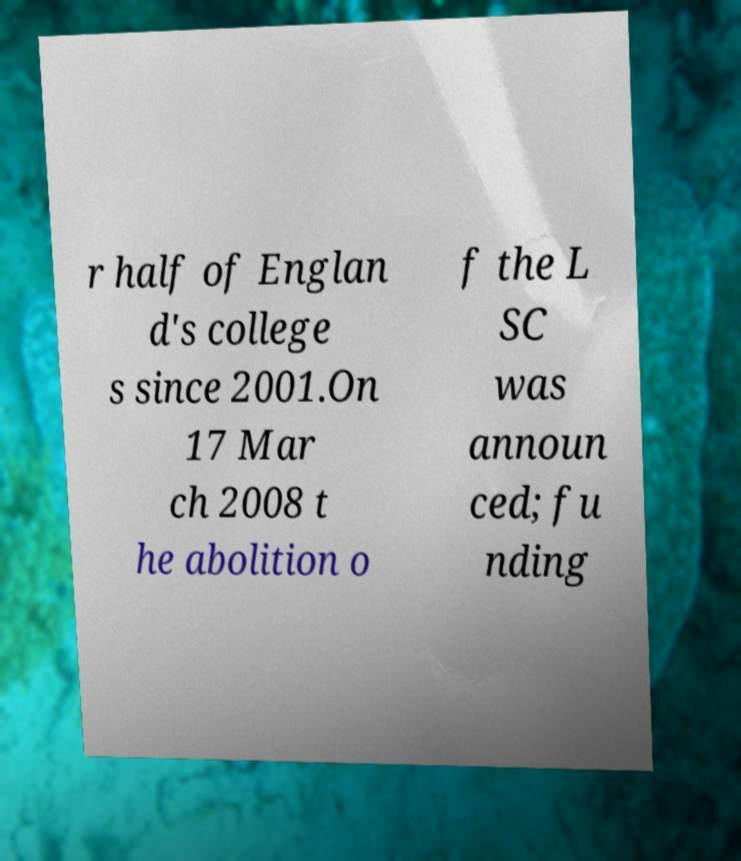Please identify and transcribe the text found in this image. r half of Englan d's college s since 2001.On 17 Mar ch 2008 t he abolition o f the L SC was announ ced; fu nding 